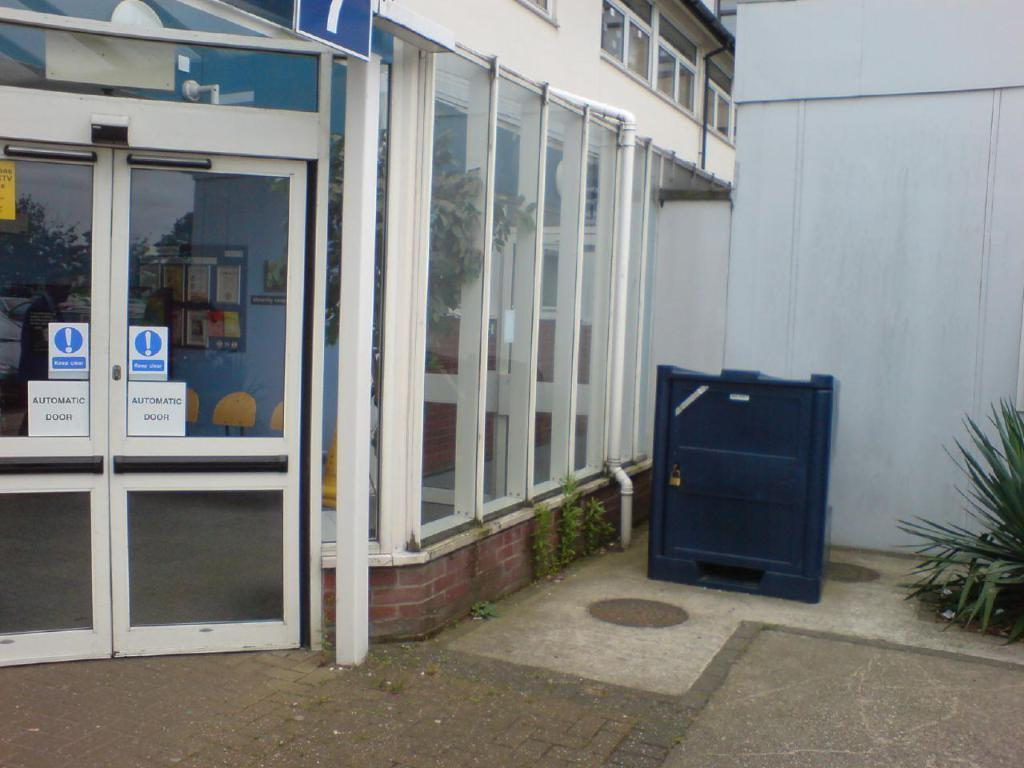What type of doors can be seen in the image? There are glass doors in the image. What other objects or elements are present in the image? There are plants and a wall in the image. Can you describe any other objects or materials in the image? There is a metal object in the image. Who is the creator of the plants in the image? There is no information about the creator of the plants in the image. The plants are natural organisms and do not have a specific creator. 